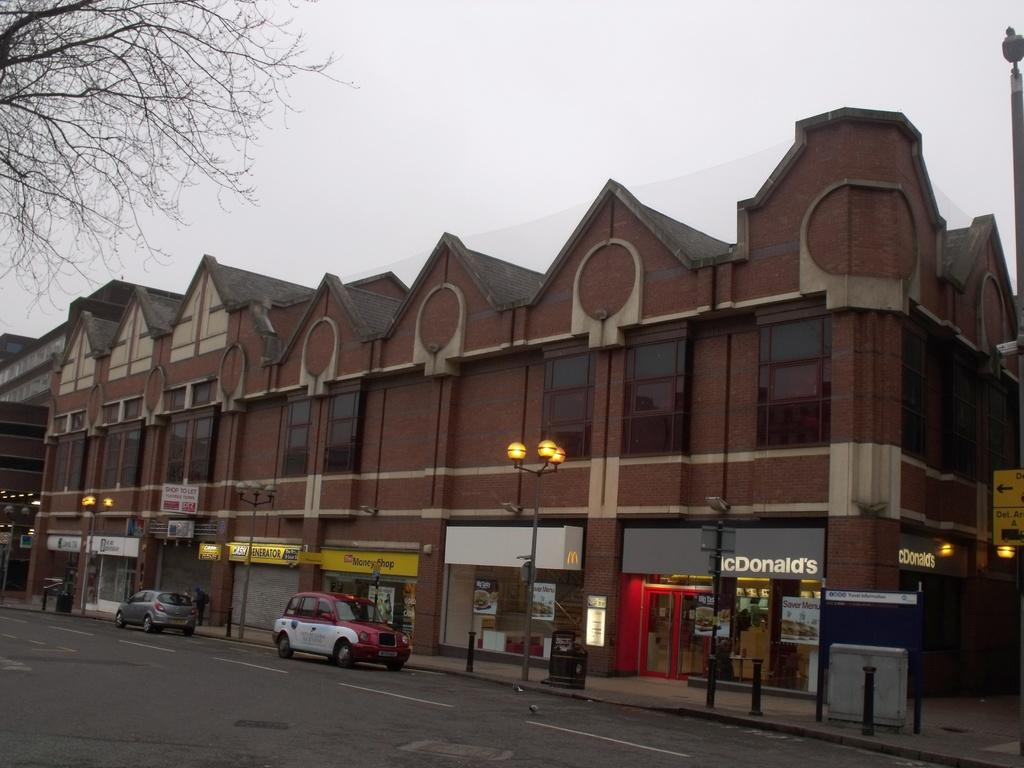<image>
Present a compact description of the photo's key features. A brown store front building with Mcdonald's at the end of the building. 